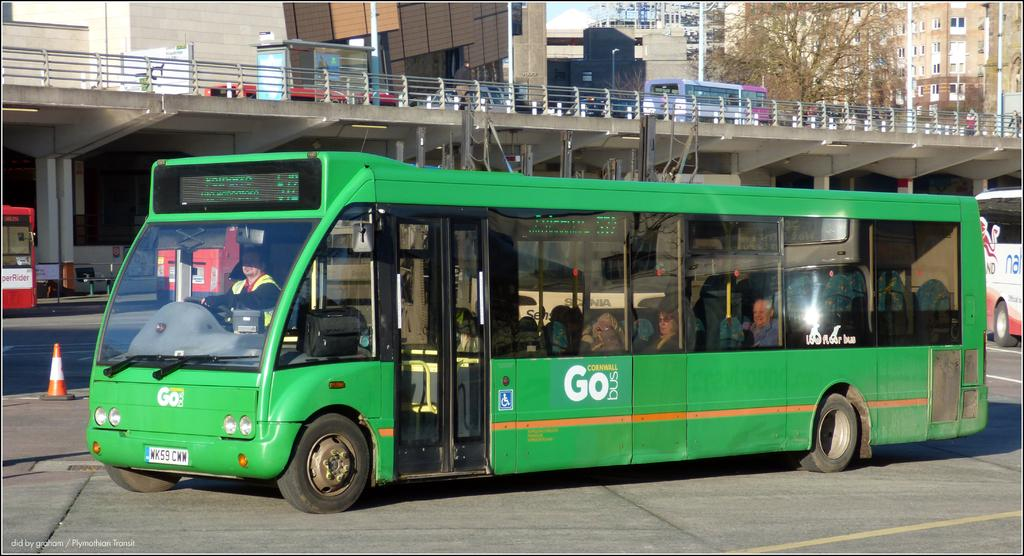<image>
Describe the image concisely. A green Cornwall Go bus with license plate WK59 CWW. 